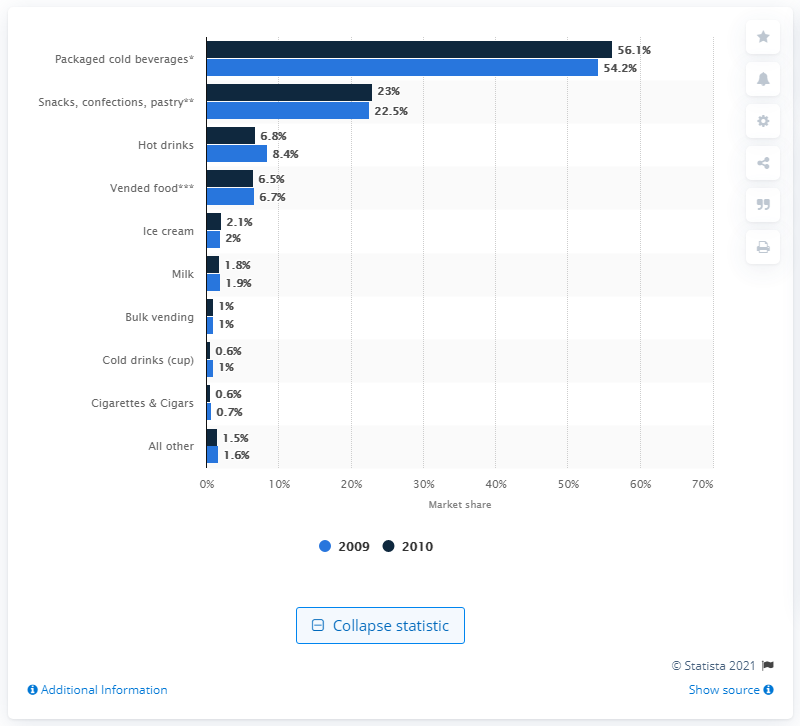Give some essential details in this illustration. In 2009, approximately 8.4% of the total products sold through vending machines were hot drinks. 